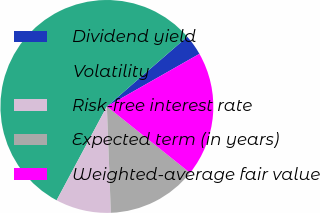Convert chart. <chart><loc_0><loc_0><loc_500><loc_500><pie_chart><fcel>Dividend yield<fcel>Volatility<fcel>Risk-free interest rate<fcel>Expected term (in years)<fcel>Weighted-average fair value<nl><fcel>3.15%<fcel>55.8%<fcel>8.42%<fcel>13.68%<fcel>18.95%<nl></chart> 